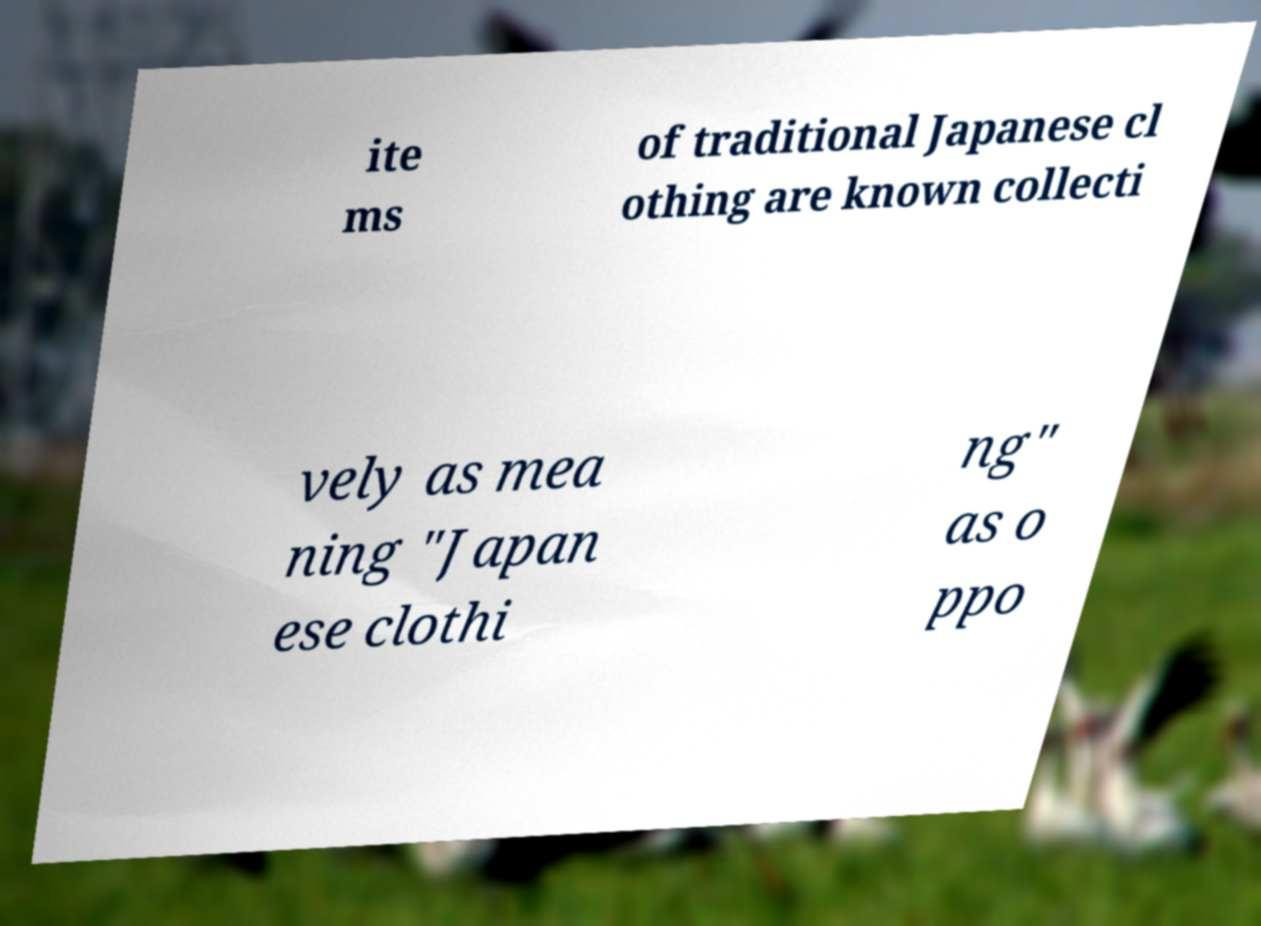Please read and relay the text visible in this image. What does it say? ite ms of traditional Japanese cl othing are known collecti vely as mea ning "Japan ese clothi ng" as o ppo 